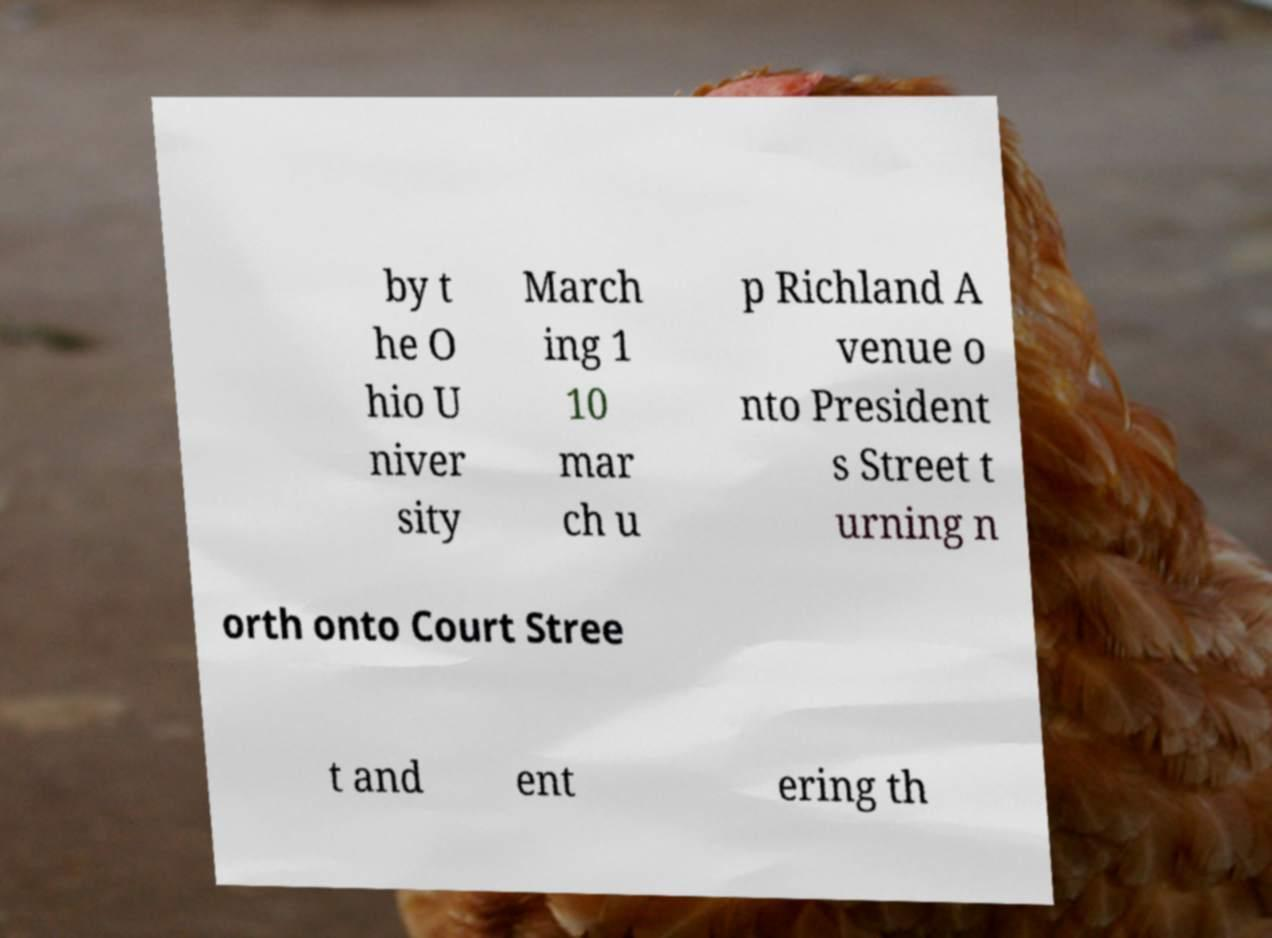Please identify and transcribe the text found in this image. by t he O hio U niver sity March ing 1 10 mar ch u p Richland A venue o nto President s Street t urning n orth onto Court Stree t and ent ering th 